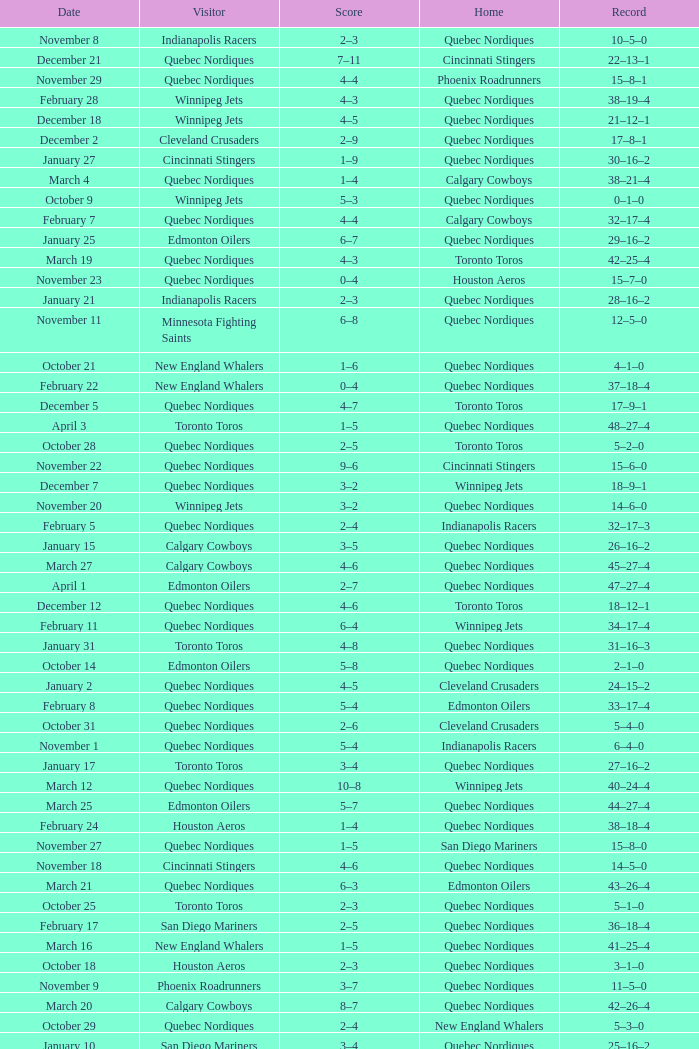What was the date of the game with a score of 2–1? November 30. 